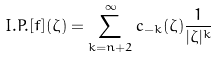Convert formula to latex. <formula><loc_0><loc_0><loc_500><loc_500>I . P . [ f ] ( \zeta ) = \sum _ { k = n + 2 } ^ { \infty } c _ { - k } ( \zeta ) \frac { 1 } { | \zeta | ^ { k } }</formula> 